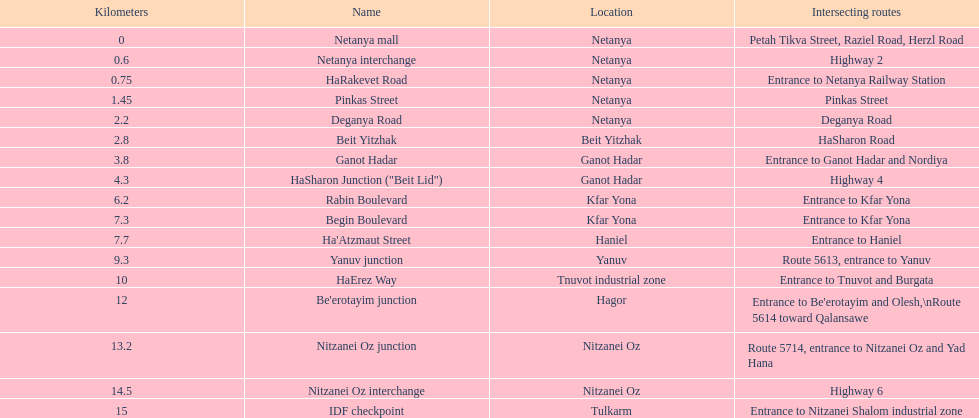What area succeeds kfar yona? Haniel. 